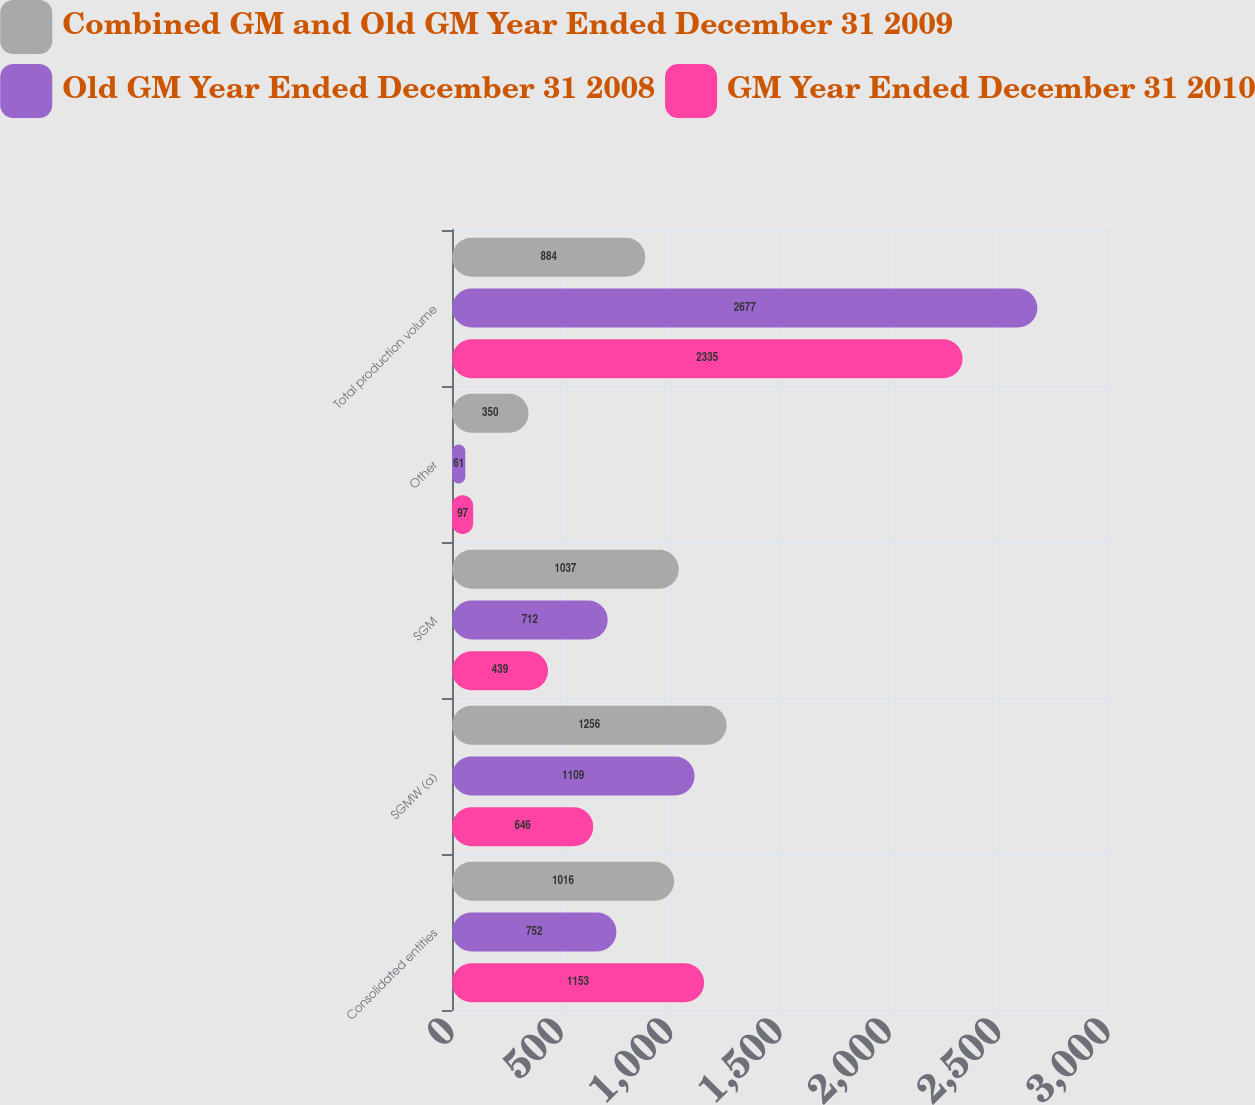<chart> <loc_0><loc_0><loc_500><loc_500><stacked_bar_chart><ecel><fcel>Consolidated entities<fcel>SGMW (a)<fcel>SGM<fcel>Other<fcel>Total production volume<nl><fcel>Combined GM and Old GM Year Ended December 31 2009<fcel>1016<fcel>1256<fcel>1037<fcel>350<fcel>884<nl><fcel>Old GM Year Ended December 31 2008<fcel>752<fcel>1109<fcel>712<fcel>61<fcel>2677<nl><fcel>GM Year Ended December 31 2010<fcel>1153<fcel>646<fcel>439<fcel>97<fcel>2335<nl></chart> 